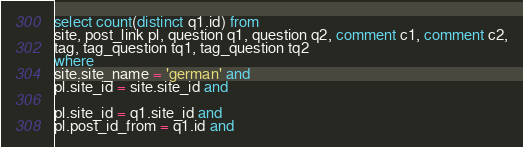Convert code to text. <code><loc_0><loc_0><loc_500><loc_500><_SQL_>
select count(distinct q1.id) from
site, post_link pl, question q1, question q2, comment c1, comment c2,
tag, tag_question tq1, tag_question tq2
where
site.site_name = 'german' and
pl.site_id = site.site_id and

pl.site_id = q1.site_id and
pl.post_id_from = q1.id and</code> 